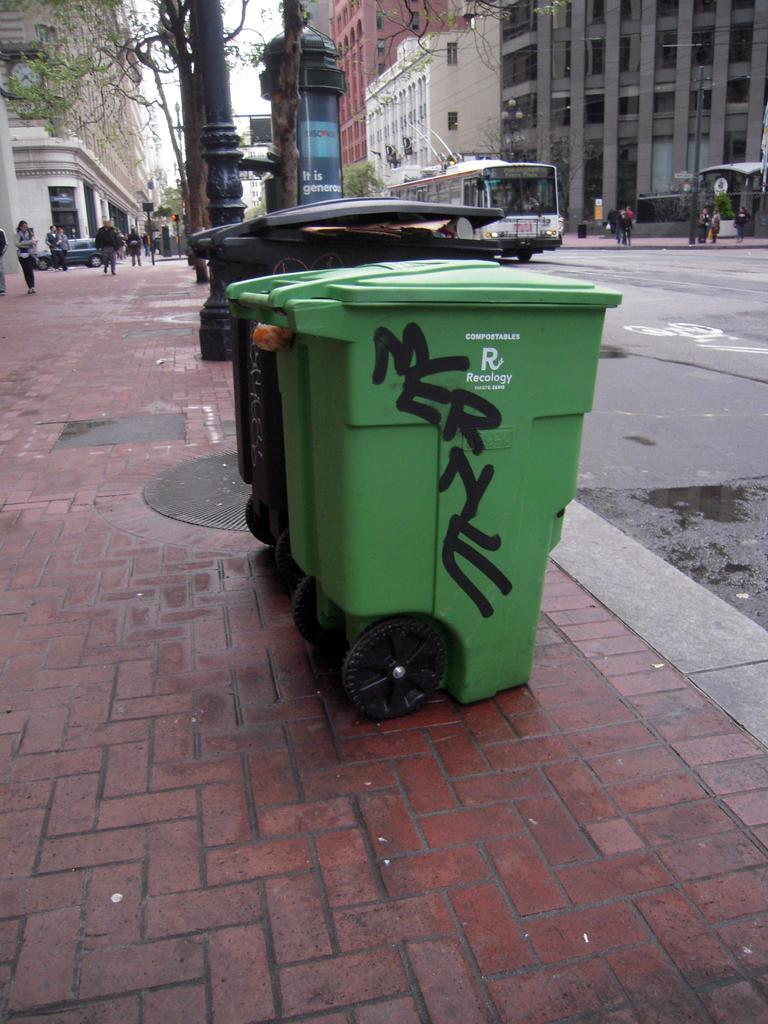Provide a one-sentence caption for the provided image. Two large trash cans, one balck the other green taht has the word MERNE spraypainted on it. 